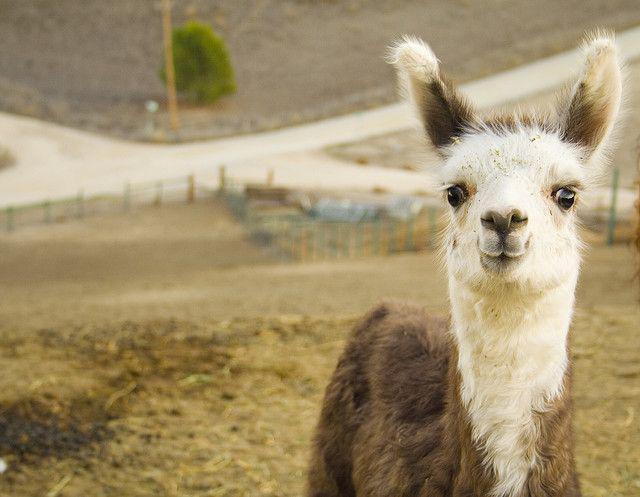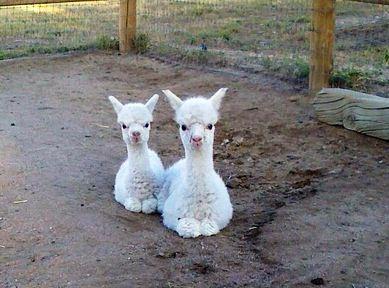The first image is the image on the left, the second image is the image on the right. Analyze the images presented: Is the assertion "The left image contains one standing brown-and-white llama, and the right image contains at least two all white llamas." valid? Answer yes or no. Yes. The first image is the image on the left, the second image is the image on the right. Given the left and right images, does the statement "There are four llamas." hold true? Answer yes or no. No. 